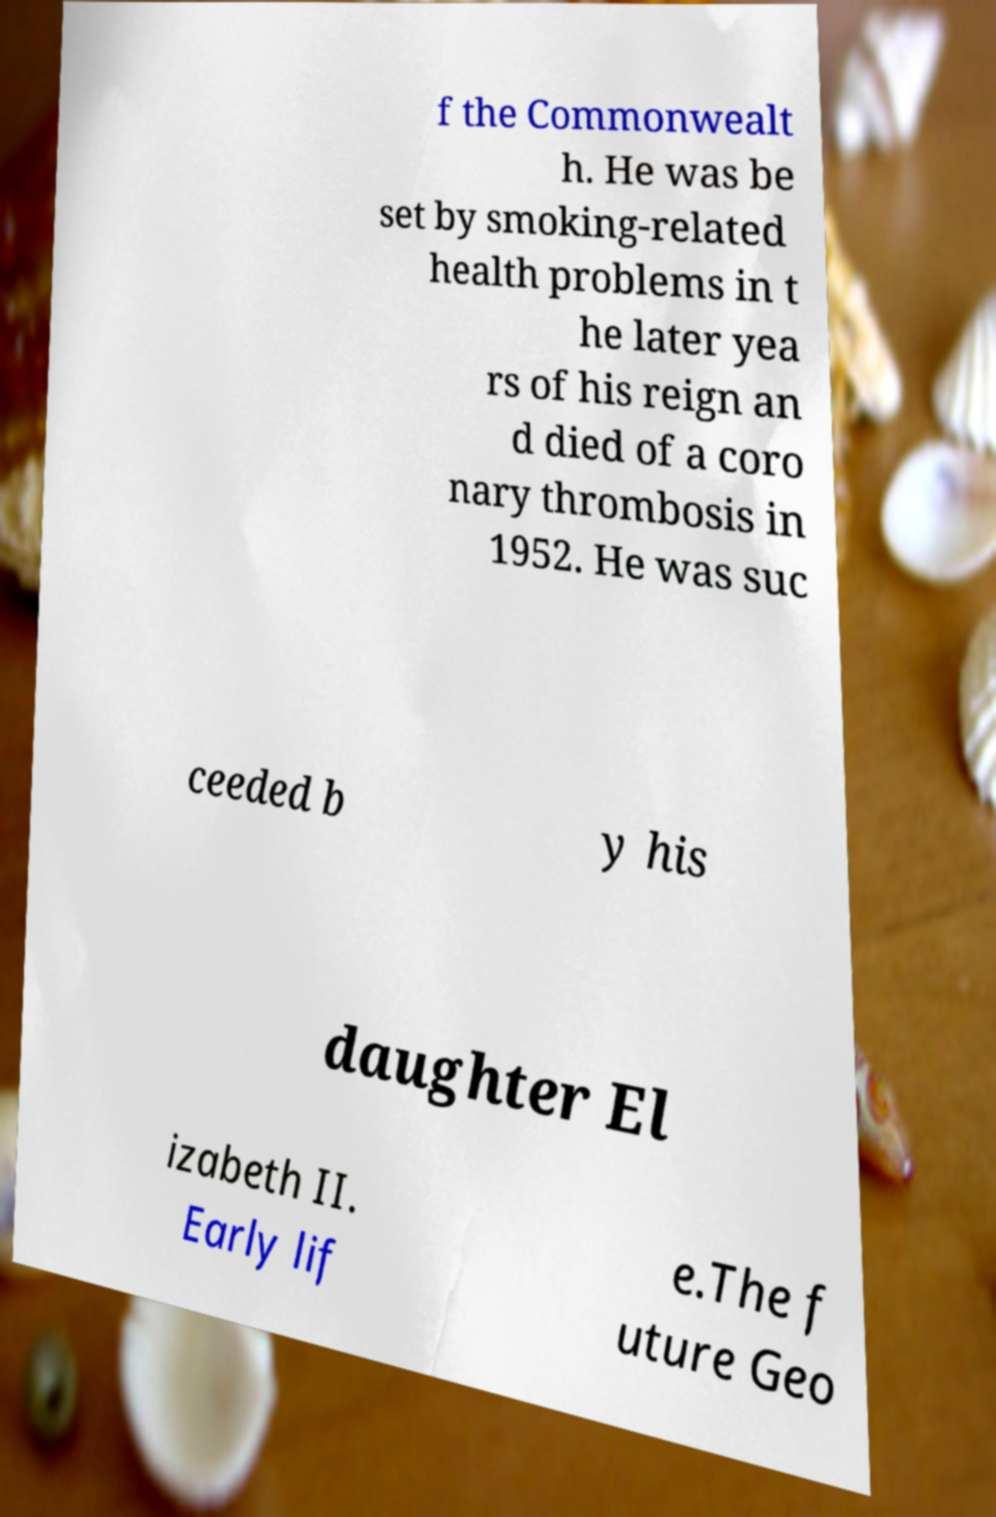Could you extract and type out the text from this image? f the Commonwealt h. He was be set by smoking-related health problems in t he later yea rs of his reign an d died of a coro nary thrombosis in 1952. He was suc ceeded b y his daughter El izabeth II. Early lif e.The f uture Geo 